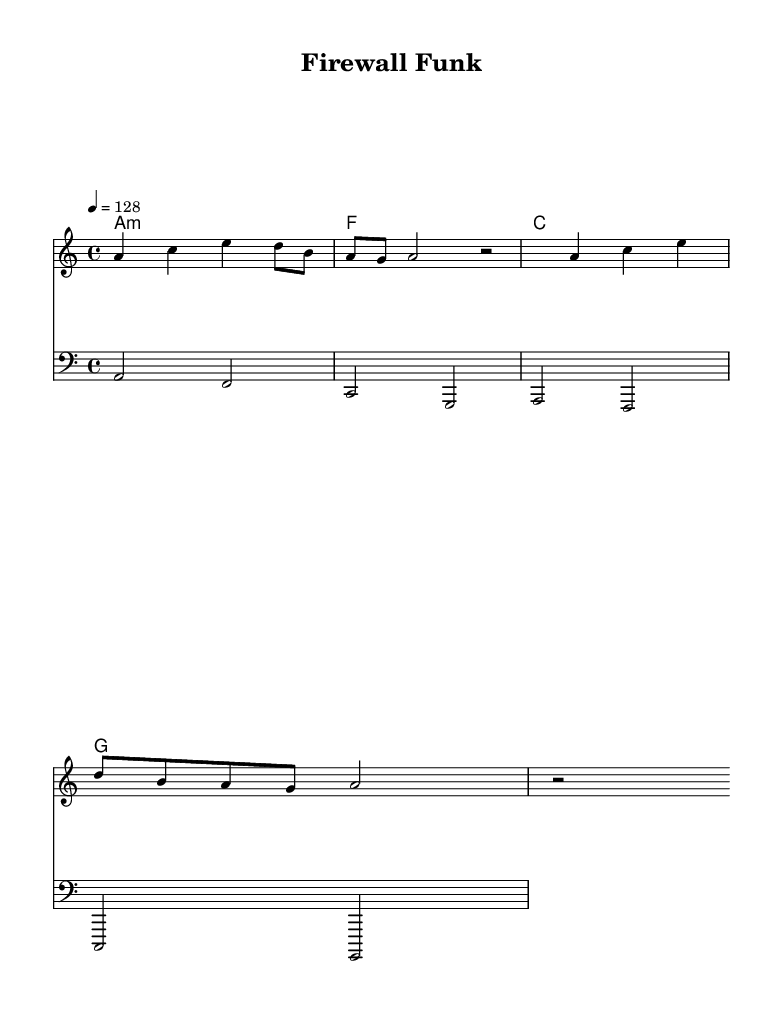What is the key signature of this music? The key signature is A minor, which contains no sharps or flats. It is indicated at the beginning of the staff.
Answer: A minor What is the time signature of this music? The time signature is 4/4, which means there are four beats in a measure and the quarter note gets one beat. This is shown at the beginning of the score.
Answer: 4/4 What is the tempo marking for this piece? The tempo marking is 128 beats per minute, indicated by the notation "4 = 128". This suggests the speed at which the piece should be played.
Answer: 128 How many measures are there in the melody? There are four measures in the melody section, as counted by the grouping of notes and the presence of bar lines in the melody staff.
Answer: 4 What type of music is this? This piece is classified as House music, which is characterized by its danceable beat and electronic sounds, often featuring repetitive rhythms and a 4/4 time signature; both qualities are evident in this piece.
Answer: House What is the main lyric theme of this song? The main theme of the lyrics is data security, which is explicitly reflected in the phrases about encrypting data and securing against hackers, indicating a focus on technology and protection.
Answer: Data security What are the chord symbols used in this composition? The chord symbols include A minor, F, C, and G, which are written above the staff in chord name notation. These chords form the harmonic foundation for the melody.
Answer: A minor, F, C, G 